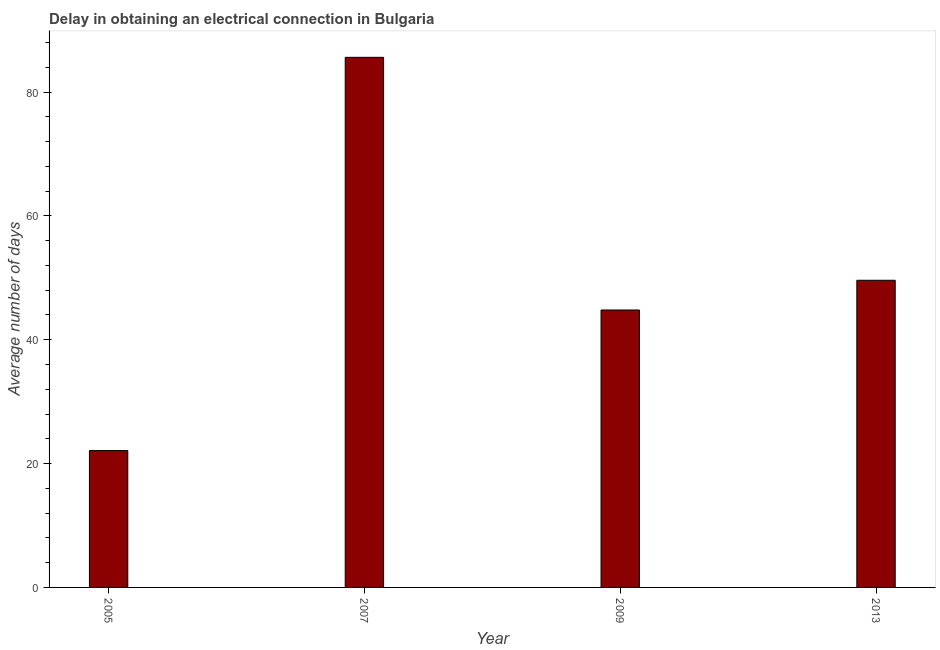Does the graph contain any zero values?
Keep it short and to the point. No. What is the title of the graph?
Your answer should be compact. Delay in obtaining an electrical connection in Bulgaria. What is the label or title of the X-axis?
Offer a terse response. Year. What is the label or title of the Y-axis?
Offer a terse response. Average number of days. What is the dalay in electrical connection in 2013?
Your response must be concise. 49.6. Across all years, what is the maximum dalay in electrical connection?
Your answer should be very brief. 85.6. Across all years, what is the minimum dalay in electrical connection?
Offer a terse response. 22.1. In which year was the dalay in electrical connection maximum?
Keep it short and to the point. 2007. In which year was the dalay in electrical connection minimum?
Your response must be concise. 2005. What is the sum of the dalay in electrical connection?
Your response must be concise. 202.1. What is the difference between the dalay in electrical connection in 2005 and 2009?
Ensure brevity in your answer.  -22.7. What is the average dalay in electrical connection per year?
Your answer should be very brief. 50.52. What is the median dalay in electrical connection?
Provide a short and direct response. 47.2. What is the ratio of the dalay in electrical connection in 2005 to that in 2013?
Give a very brief answer. 0.45. What is the difference between the highest and the second highest dalay in electrical connection?
Ensure brevity in your answer.  36. What is the difference between the highest and the lowest dalay in electrical connection?
Provide a succinct answer. 63.5. In how many years, is the dalay in electrical connection greater than the average dalay in electrical connection taken over all years?
Your answer should be very brief. 1. What is the difference between two consecutive major ticks on the Y-axis?
Make the answer very short. 20. Are the values on the major ticks of Y-axis written in scientific E-notation?
Keep it short and to the point. No. What is the Average number of days of 2005?
Make the answer very short. 22.1. What is the Average number of days in 2007?
Make the answer very short. 85.6. What is the Average number of days of 2009?
Keep it short and to the point. 44.8. What is the Average number of days in 2013?
Give a very brief answer. 49.6. What is the difference between the Average number of days in 2005 and 2007?
Your response must be concise. -63.5. What is the difference between the Average number of days in 2005 and 2009?
Provide a short and direct response. -22.7. What is the difference between the Average number of days in 2005 and 2013?
Your answer should be very brief. -27.5. What is the difference between the Average number of days in 2007 and 2009?
Offer a terse response. 40.8. What is the difference between the Average number of days in 2009 and 2013?
Ensure brevity in your answer.  -4.8. What is the ratio of the Average number of days in 2005 to that in 2007?
Provide a succinct answer. 0.26. What is the ratio of the Average number of days in 2005 to that in 2009?
Give a very brief answer. 0.49. What is the ratio of the Average number of days in 2005 to that in 2013?
Your answer should be compact. 0.45. What is the ratio of the Average number of days in 2007 to that in 2009?
Your answer should be very brief. 1.91. What is the ratio of the Average number of days in 2007 to that in 2013?
Give a very brief answer. 1.73. What is the ratio of the Average number of days in 2009 to that in 2013?
Make the answer very short. 0.9. 